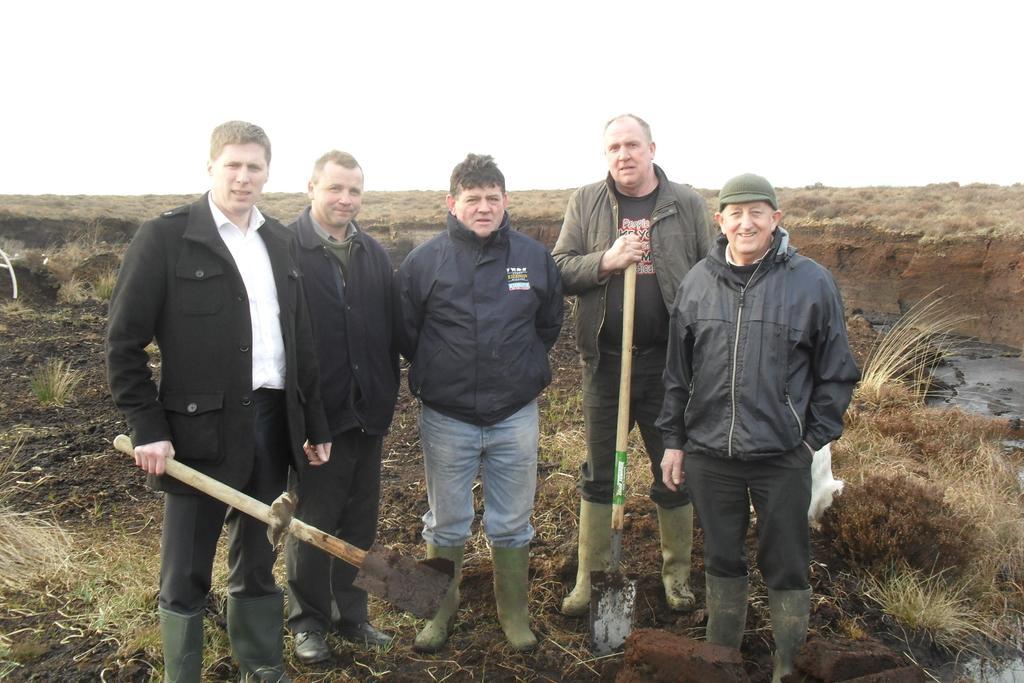How would you summarize this image in a sentence or two? In this picture we can see ground, plants, grass. We can see the men are standing. Few men are holding tools. 